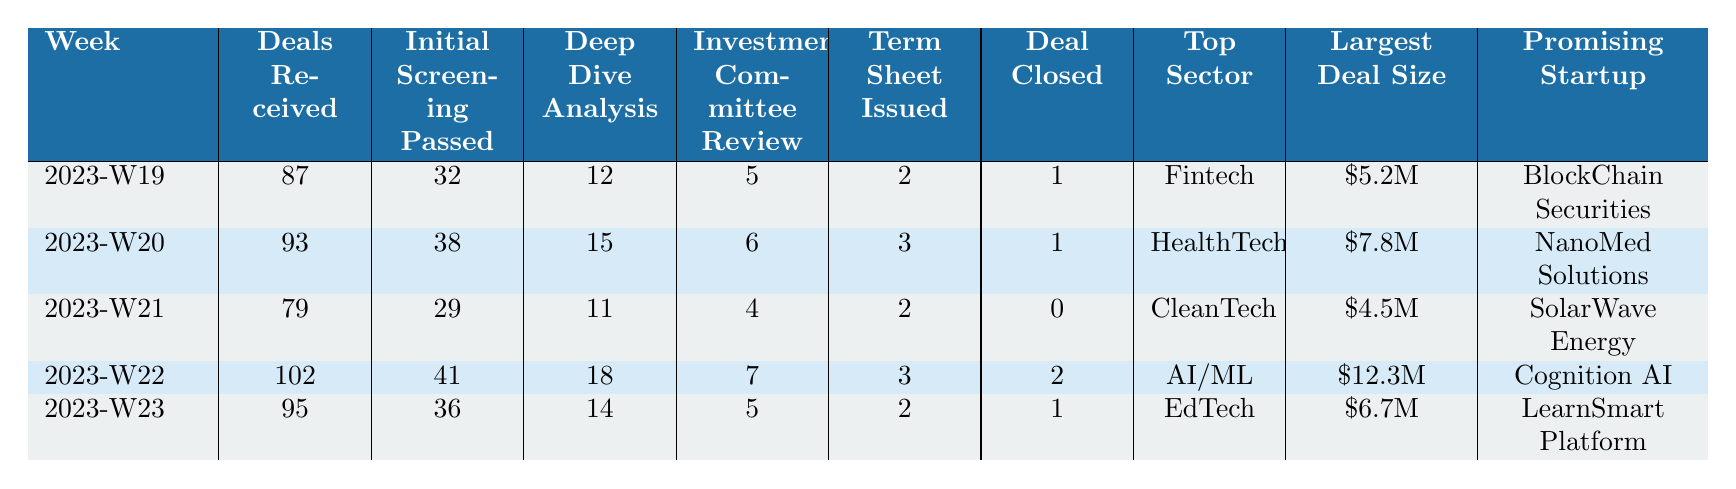What was the largest deal size in week 2023-W22? According to the table, the largest deal size in week 2023-W22 is $12.3M.
Answer: $12.3M How many deals were received in week 2023-W20? From the table, week 2023-W20 shows that 93 deals were received.
Answer: 93 What is the total number of deals closed from weeks 2023-W19 to 2023-W23? To find the total number of deals closed, we add the deals closed for each week: 1 (W19) + 1 (W20) + 0 (W21) + 2 (W22) + 1 (W23) = 5.
Answer: 5 Which week had the highest number of initial screenings passed? Week 2023-W22 had 41 initial screenings passed, which is higher than the other weeks.
Answer: 2023-W22 Is the promising startup for week 2023-W21 SolarWave Energy? Yes, the table clearly lists SolarWave Energy as the promising startup for week 2023-W21.
Answer: Yes What is the percentage of deals that passed initial screening in week 2023-W23? To find the percentage, we calculate (36 initial screenings passed / 95 deals received) * 100 = 37.89%. Therefore, the percentage is approximately 37.9%.
Answer: 37.9% What is the total number of deep dive analyses conducted over the weeks? We sum the deep dive analyses for each week: 12 (W19) + 15 (W20) + 11 (W21) + 18 (W22) + 14 (W23) = 70.
Answer: 70 What was the top sector for week 2023-W21? According to the table, the top sector for week 2023-W21 is CleanTech.
Answer: CleanTech Which week had the most deals received and how many? Week 2023-W22 had the most deals received, totaling 102.
Answer: 2023-W22, 102 Did the number of deals received increase or decrease from week 2023-W20 to week 2023-W21? From week 2023-W20 (93 deals) to week 2023-W21 (79 deals), the number of deals received decreased.
Answer: Decreased 